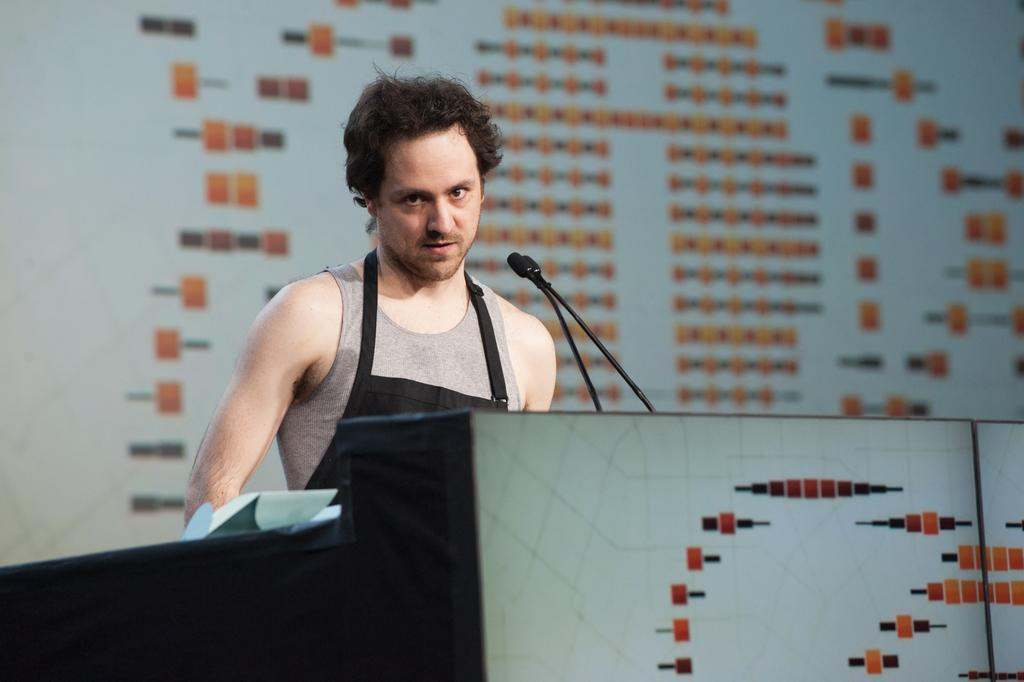Who or what is the main subject in the image? There is a person in the image. What is the person doing in the image? The person is behind a podium. What object is the person holding in the image? The person is holding a microphone. What else can be seen in the image besides the person? There are papers in the image. What is visible in the background of the image? There is a wall in the background of the image. What type of coach can be seen in the image? There is no coach present in the image. 